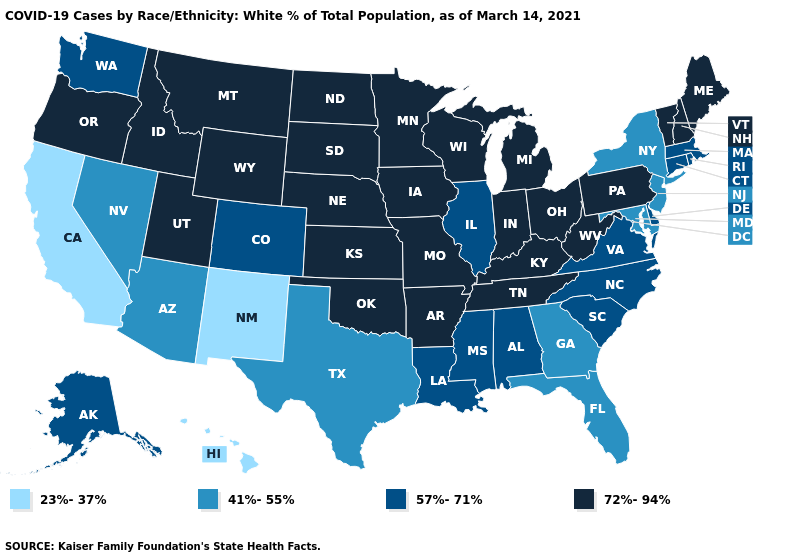Which states have the lowest value in the USA?
Answer briefly. California, Hawaii, New Mexico. What is the value of Kentucky?
Be succinct. 72%-94%. Name the states that have a value in the range 23%-37%?
Be succinct. California, Hawaii, New Mexico. What is the value of Rhode Island?
Be succinct. 57%-71%. Name the states that have a value in the range 57%-71%?
Answer briefly. Alabama, Alaska, Colorado, Connecticut, Delaware, Illinois, Louisiana, Massachusetts, Mississippi, North Carolina, Rhode Island, South Carolina, Virginia, Washington. Which states have the highest value in the USA?
Quick response, please. Arkansas, Idaho, Indiana, Iowa, Kansas, Kentucky, Maine, Michigan, Minnesota, Missouri, Montana, Nebraska, New Hampshire, North Dakota, Ohio, Oklahoma, Oregon, Pennsylvania, South Dakota, Tennessee, Utah, Vermont, West Virginia, Wisconsin, Wyoming. What is the value of Delaware?
Write a very short answer. 57%-71%. Does Indiana have the highest value in the MidWest?
Write a very short answer. Yes. What is the lowest value in states that border Pennsylvania?
Short answer required. 41%-55%. What is the lowest value in states that border Missouri?
Short answer required. 57%-71%. What is the highest value in states that border New Mexico?
Concise answer only. 72%-94%. Does the map have missing data?
Quick response, please. No. Is the legend a continuous bar?
Give a very brief answer. No. Does the first symbol in the legend represent the smallest category?
Give a very brief answer. Yes. Name the states that have a value in the range 23%-37%?
Write a very short answer. California, Hawaii, New Mexico. 